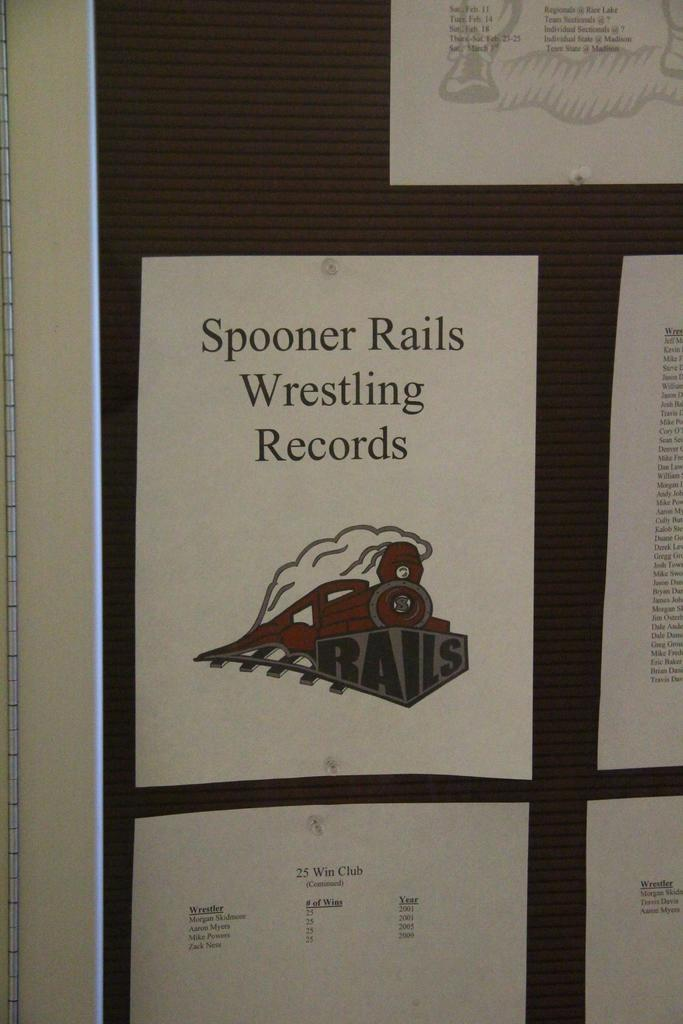<image>
Offer a succinct explanation of the picture presented. A piece of paper with spooner rails wrestling records on it. 